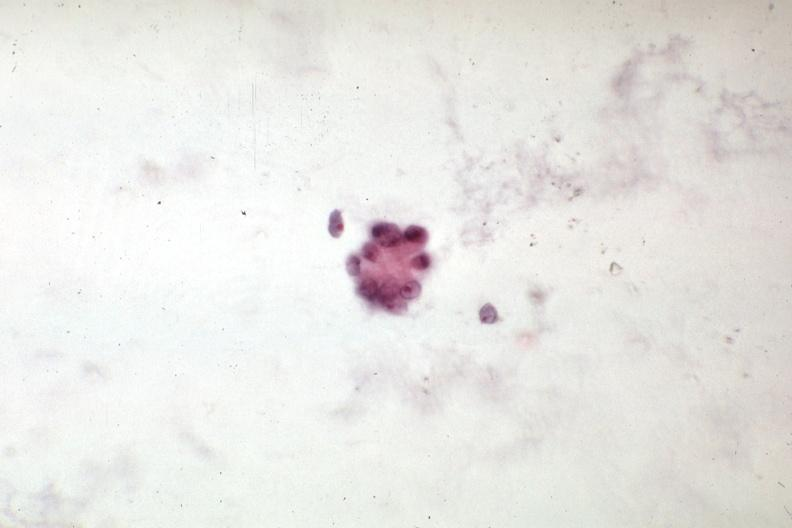s slices of liver and spleen typical tuberculous exudate is present on capsule of liver and spleen present?
Answer the question using a single word or phrase. No 